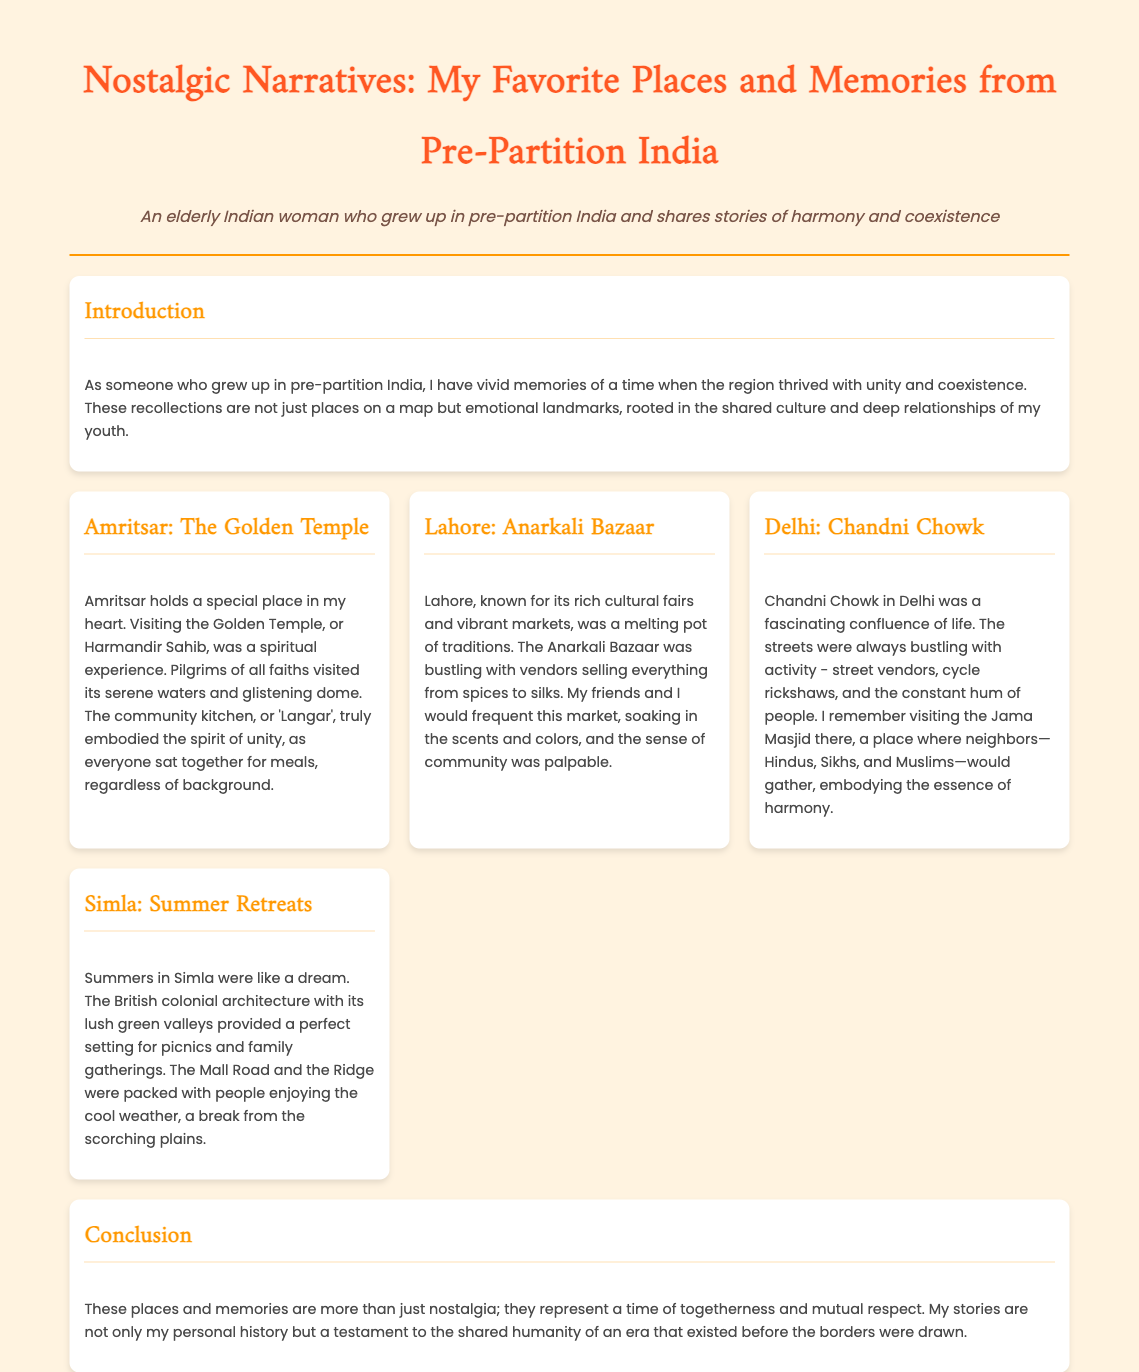What is the title of the presentation? The title of the presentation is provided in the header section of the document.
Answer: Nostalgic Narratives: My Favorite Places and Memories from Pre-Partition India Who is the persona of the presenter? The persona is described in the header and reflects the identity of the speaker sharing their experiences.
Answer: An elderly Indian woman What is the first location mentioned in the presentation? The first section after the introduction discusses a specific location fondly remembered by the presenter.
Answer: Amritsar: The Golden Temple What unique feature of Amritsar is highlighted? The document mentions an important aspect of the Golden Temple experience that reflects community values.
Answer: Langar Which market in Lahore is described? The presentation details a vibrant market in Lahore known for its cultural significance.
Answer: Anarkali Bazaar How does the presenter characterize Chandni Chowk? The text describes this location's atmosphere and the diversity of the people visiting there.
Answer: A fascinating confluence of life What time of year is associated with memories of Simla? The document references a specific season during which the presenter reminisces about experiences in Simla.
Answer: Summers What theme is emphasized in the conclusion? The concluding remarks highlight a specific social aspect of pre-partition India that the presenter wants to convey.
Answer: Togetherness and mutual respect 